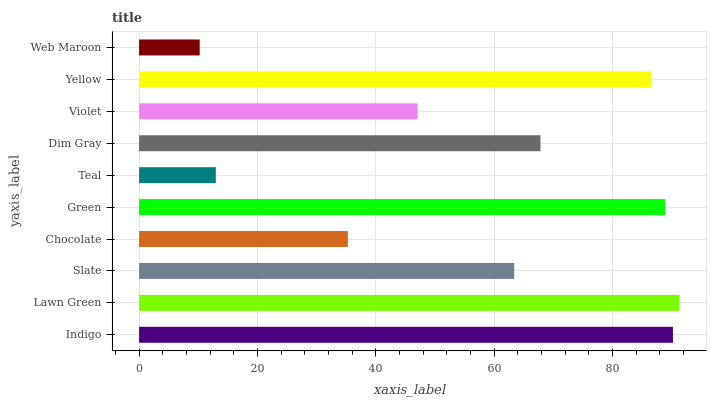Is Web Maroon the minimum?
Answer yes or no. Yes. Is Lawn Green the maximum?
Answer yes or no. Yes. Is Slate the minimum?
Answer yes or no. No. Is Slate the maximum?
Answer yes or no. No. Is Lawn Green greater than Slate?
Answer yes or no. Yes. Is Slate less than Lawn Green?
Answer yes or no. Yes. Is Slate greater than Lawn Green?
Answer yes or no. No. Is Lawn Green less than Slate?
Answer yes or no. No. Is Dim Gray the high median?
Answer yes or no. Yes. Is Slate the low median?
Answer yes or no. Yes. Is Chocolate the high median?
Answer yes or no. No. Is Green the low median?
Answer yes or no. No. 